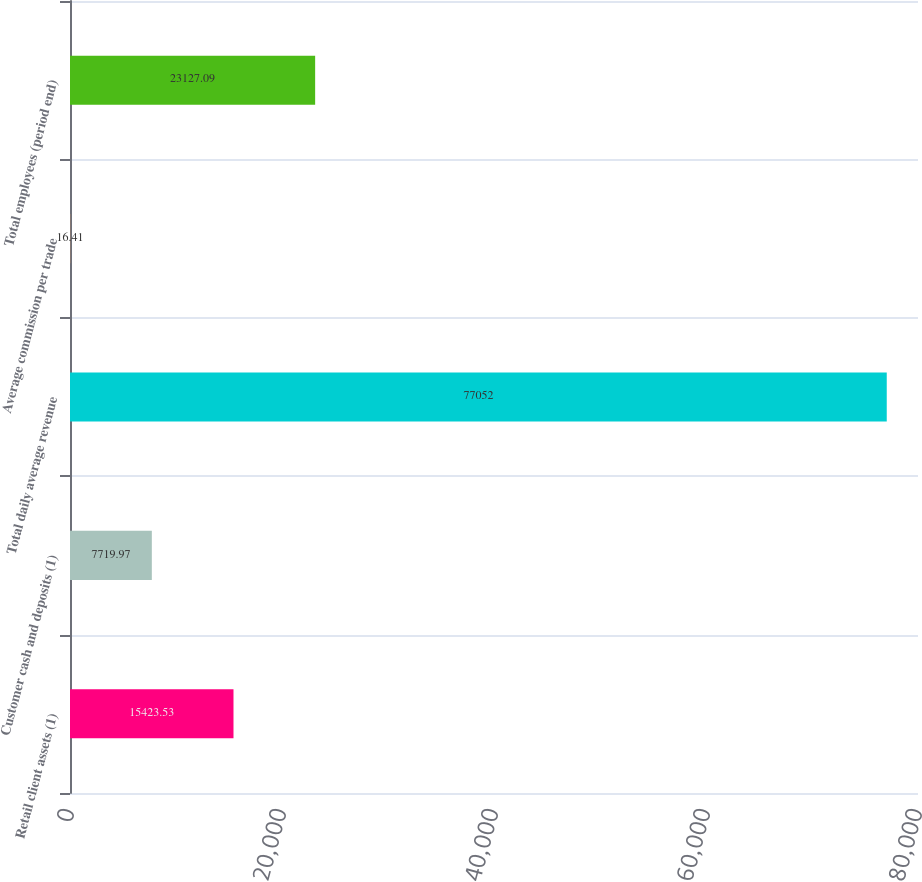Convert chart to OTSL. <chart><loc_0><loc_0><loc_500><loc_500><bar_chart><fcel>Retail client assets (1)<fcel>Customer cash and deposits (1)<fcel>Total daily average revenue<fcel>Average commission per trade<fcel>Total employees (period end)<nl><fcel>15423.5<fcel>7719.97<fcel>77052<fcel>16.41<fcel>23127.1<nl></chart> 